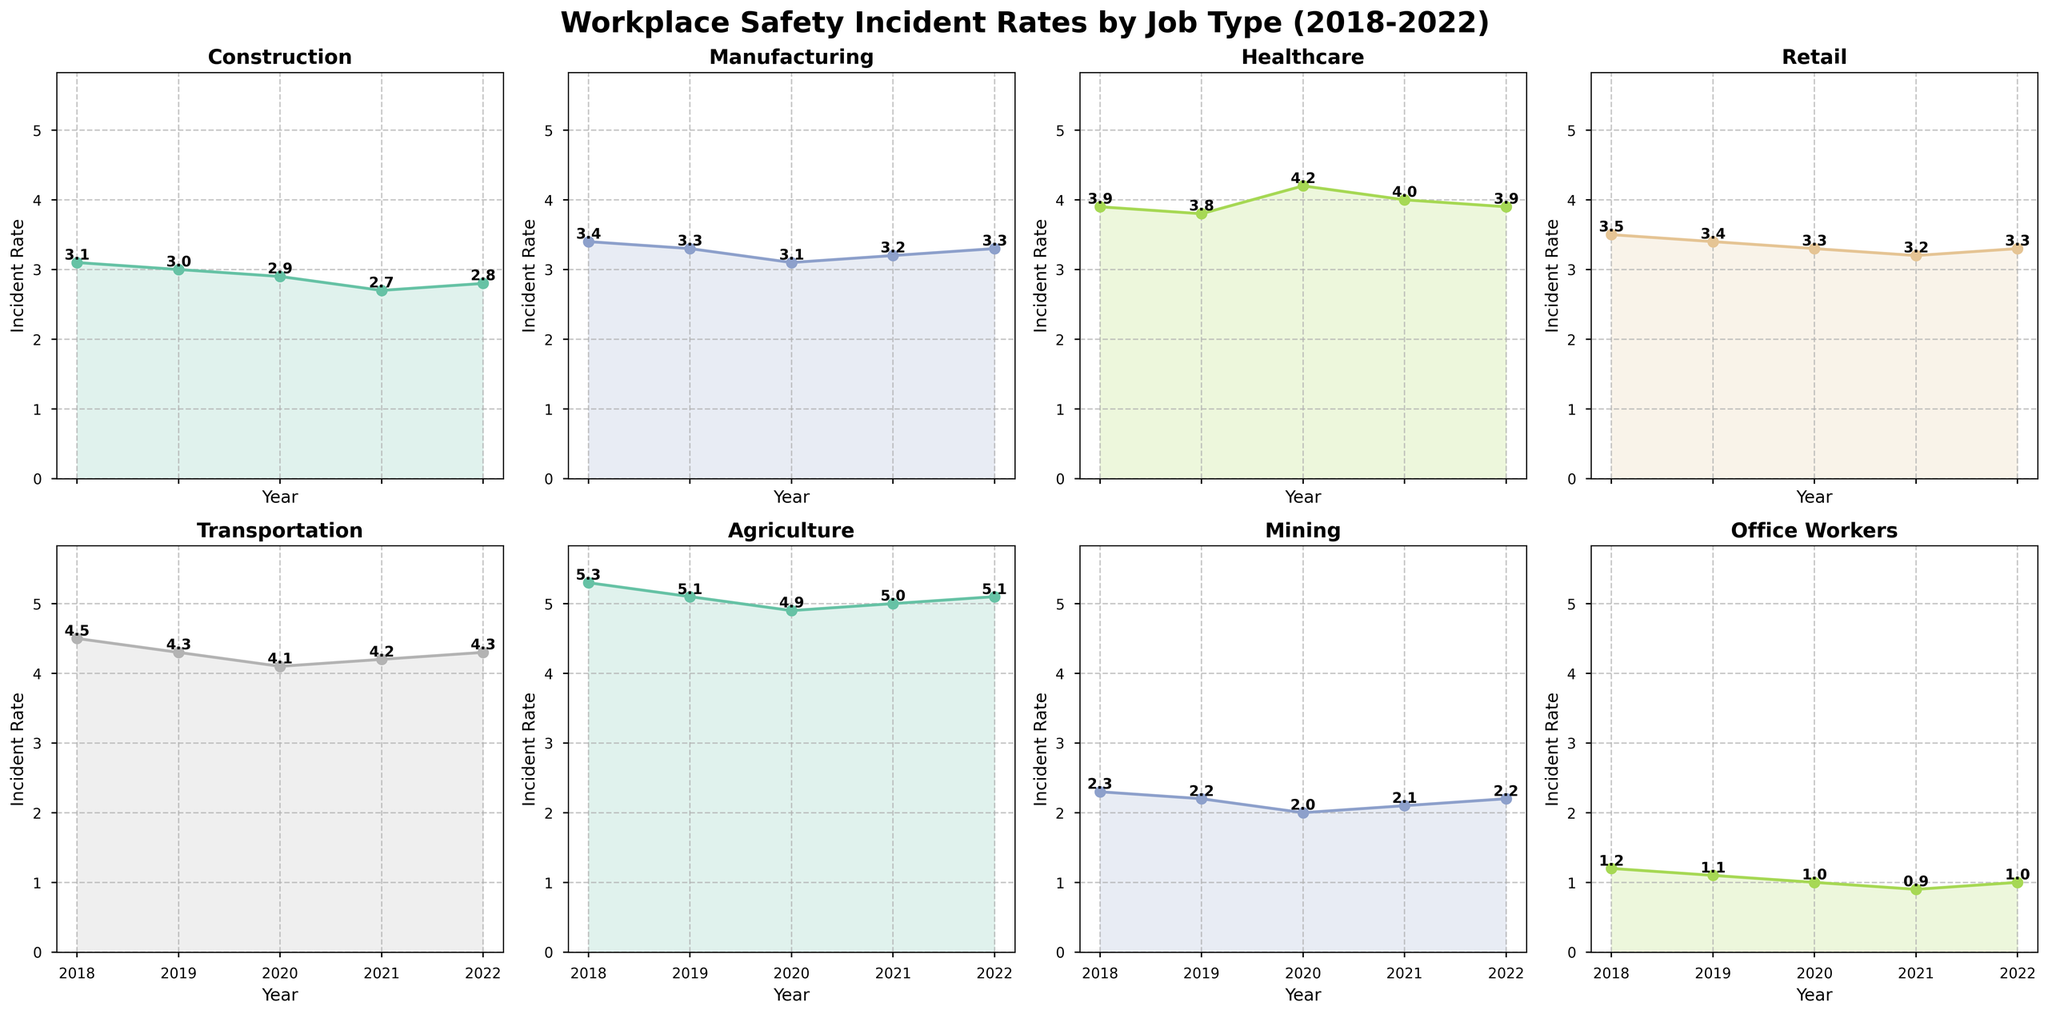What job type has the highest incident rate in 2022? By looking at the subplot titles and the incident rates plotted for each job type in 2022, we can find the one with the highest value. The Agriculture plot shows 5.1 for 2022, which is the highest among all job types.
Answer: Agriculture Which job type showed the largest decrease in incident rate from 2018 to 2022? We need to compare the incident rates of 2018 and 2022 for each job type. Mining decreased from 2.3 in 2018 to 2.2 in 2022, which is a 0.1 decrease. However, Office_Workers decreased from 1.2 in 2018 to 1.0 in 2022, showing a 0.2 decrease.
Answer: Office_Workers Between 2018 and 2022, which job type had the most stable incident rate? To determine stability, look for the smallest range (difference between the highest and lowest values) over the years. Office_Workers had its incident rate between 0.9 and 1.2, a range of 0.3, which is the smallest among all job types.
Answer: Office_Workers Which job types experienced an increase in incident rates from 2021 to 2022? Compare the incident rates from 2021 and 2022 for each job type. Construction, Manufacturing, Transportation, Agriculture, and Office_Workers all show an increase in incident rates from 2021 to 2022.
Answer: Construction, Manufacturing, Transportation, Agriculture, Office_Workers What is the average incident rate for Healthcare between 2018 and 2022? Add up the values for Healthcare from 2018 to 2022 (3.9, 3.8, 4.2, 4.0, 3.9), which total to 19.8. Then, divide by the number of years (5). So, 19.8 / 5 = 3.96.
Answer: 3.96 How does the incident rate in Manufacturing in 2022 compare to that in Healthcare in the same year? Look at the 2022 incident rates for Manufacturing (3.3) and Healthcare (3.9) and compare them. The incident rate in Healthcare is higher.
Answer: Healthcare's rate is higher What was the trend in Transportation incident rates from 2018 to 2022? Observing the plot for Transportation, the incident rates are reducing from 4.5 in 2018 to 4.1 in 2020, then increasing to 4.2 in 2021 and 4.3 in 2022. Overall, there's a slight downward trend but a recent uptick.
Answer: Downtrend overall with recent uptick Which two job types had the closest incident rates in 2022? Looking at the 2022 incident rates, Retail and Manufacturing both have incident rates of 3.3.
Answer: Retail and Manufacturing Which job type had the lowest incident rate in 2020? By looking across all subplots for the year 2020, Office_Workers had the lowest rate at 1.0.
Answer: Office_Workers 